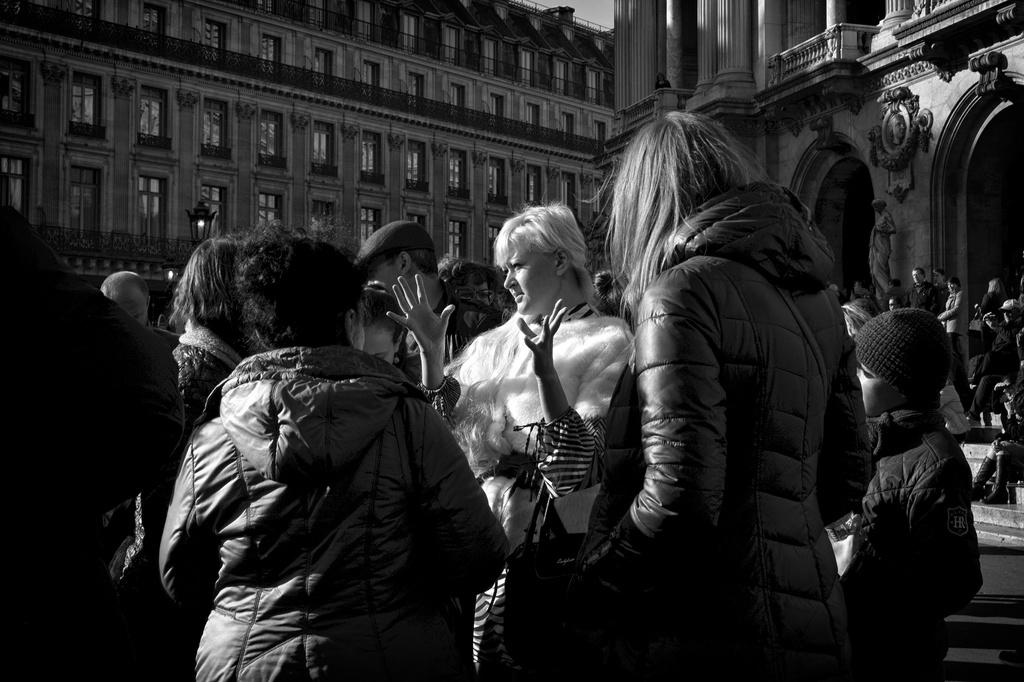What is happening in the image? There are people standing in the image. What can be seen in the distance behind the people? There are buildings in the background of the image. What type of chain is being used to adjust the height of the buildings in the image? There is no chain or adjustment visible in the image; the buildings are stationary in the background. 